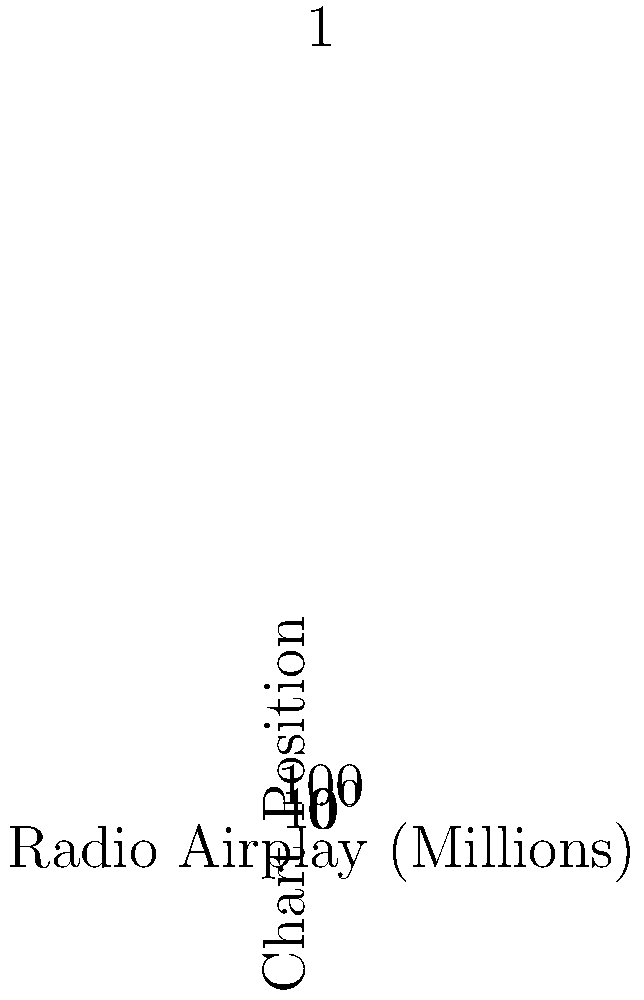As a chart-topping pop artist, you're familiar with the relationship between radio airplay and chart performance. The scatter plot above shows the correlation between radio airplay (in millions of listeners) and chart position for your latest album's singles. What type of correlation does this data suggest, and how might this information be used to strategize future single releases? To analyze the correlation and its implications:

1. Observe the overall trend: As radio airplay increases, chart position improves (moves towards 1).

2. Identify the correlation type:
   - Points form a curved line from top-left to bottom-right.
   - This suggests a negative correlation (as x increases, y decreases).
   - The curve indicates a non-linear relationship.

3. Interpret the y-axis:
   - Chart positions are typically ranked with 1 as the highest.
   - The log scale on the y-axis compresses higher numbers, emphasizing changes at the top of the charts.

4. Analyze the relationship:
   - Initial increases in airplay (1-5 million) correspond to rapid chart improvement.
   - Further increases (5-10 million) show diminishing returns in chart position.

5. Strategic implications:
   - Prioritize getting singles to the 5 million airplay mark for significant chart impact.
   - Beyond 5 million, consider cost-benefit of additional promotion vs. chart gains.
   - For new releases, target at least 5 million in airplay to compete for top chart positions.

The data suggests a strong negative, non-linear correlation between radio airplay and chart position, which can inform promotional strategies for maximizing chart performance.
Answer: Strong negative, non-linear correlation; informs promotional strategies for airplay targeting. 